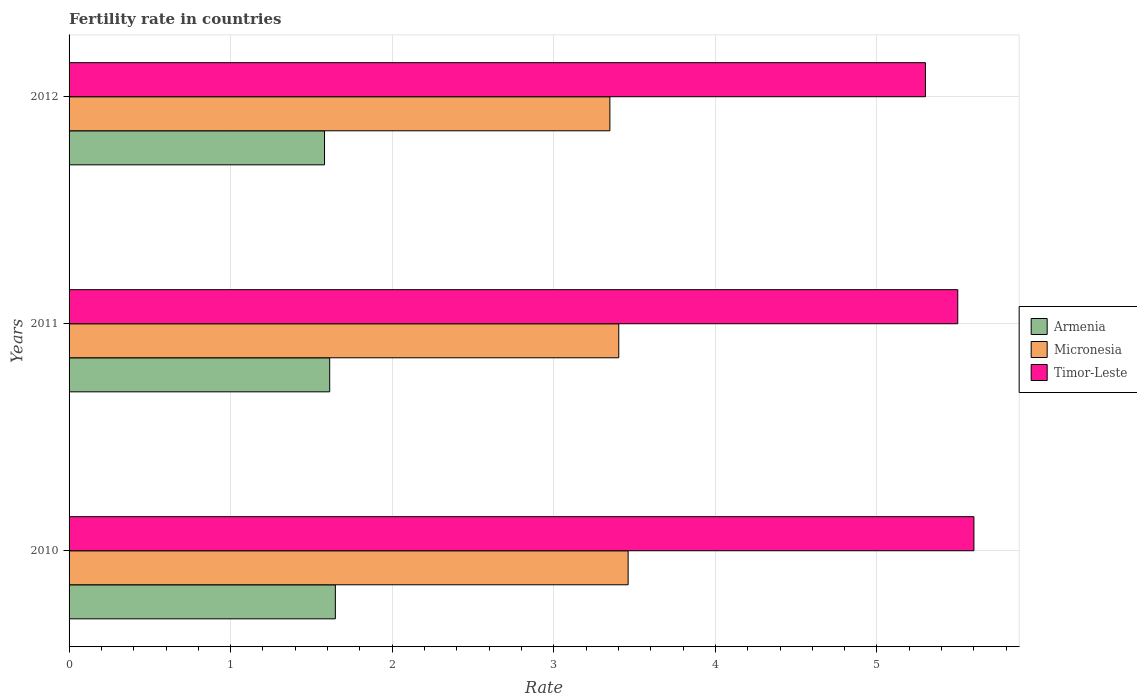How many different coloured bars are there?
Your answer should be very brief. 3. Are the number of bars per tick equal to the number of legend labels?
Offer a very short reply. Yes. Are the number of bars on each tick of the Y-axis equal?
Give a very brief answer. Yes. How many bars are there on the 2nd tick from the top?
Ensure brevity in your answer.  3. In how many cases, is the number of bars for a given year not equal to the number of legend labels?
Your answer should be compact. 0. What is the fertility rate in Armenia in 2010?
Offer a very short reply. 1.65. Across all years, what is the maximum fertility rate in Armenia?
Keep it short and to the point. 1.65. Across all years, what is the minimum fertility rate in Timor-Leste?
Offer a terse response. 5.3. What is the difference between the fertility rate in Armenia in 2010 and that in 2011?
Provide a succinct answer. 0.03. What is the difference between the fertility rate in Armenia in 2011 and the fertility rate in Micronesia in 2012?
Your response must be concise. -1.73. What is the average fertility rate in Timor-Leste per year?
Make the answer very short. 5.47. In the year 2012, what is the difference between the fertility rate in Micronesia and fertility rate in Armenia?
Offer a terse response. 1.77. In how many years, is the fertility rate in Timor-Leste greater than 3.4 ?
Provide a short and direct response. 3. What is the ratio of the fertility rate in Timor-Leste in 2010 to that in 2011?
Provide a succinct answer. 1.02. Is the fertility rate in Armenia in 2011 less than that in 2012?
Provide a short and direct response. No. Is the difference between the fertility rate in Micronesia in 2010 and 2012 greater than the difference between the fertility rate in Armenia in 2010 and 2012?
Offer a terse response. Yes. What is the difference between the highest and the second highest fertility rate in Armenia?
Provide a succinct answer. 0.03. What is the difference between the highest and the lowest fertility rate in Armenia?
Give a very brief answer. 0.07. Is the sum of the fertility rate in Armenia in 2010 and 2011 greater than the maximum fertility rate in Timor-Leste across all years?
Provide a succinct answer. No. What does the 1st bar from the top in 2010 represents?
Keep it short and to the point. Timor-Leste. What does the 1st bar from the bottom in 2010 represents?
Provide a succinct answer. Armenia. How many bars are there?
Keep it short and to the point. 9. Are all the bars in the graph horizontal?
Keep it short and to the point. Yes. How many years are there in the graph?
Offer a very short reply. 3. Are the values on the major ticks of X-axis written in scientific E-notation?
Ensure brevity in your answer.  No. Does the graph contain any zero values?
Provide a succinct answer. No. What is the title of the graph?
Your answer should be compact. Fertility rate in countries. Does "Botswana" appear as one of the legend labels in the graph?
Give a very brief answer. No. What is the label or title of the X-axis?
Offer a very short reply. Rate. What is the Rate of Armenia in 2010?
Provide a succinct answer. 1.65. What is the Rate of Micronesia in 2010?
Your answer should be very brief. 3.46. What is the Rate in Armenia in 2011?
Your answer should be compact. 1.61. What is the Rate in Micronesia in 2011?
Your answer should be compact. 3.4. What is the Rate in Timor-Leste in 2011?
Make the answer very short. 5.5. What is the Rate in Armenia in 2012?
Ensure brevity in your answer.  1.58. What is the Rate of Micronesia in 2012?
Your answer should be compact. 3.35. What is the Rate of Timor-Leste in 2012?
Provide a short and direct response. 5.3. Across all years, what is the maximum Rate of Armenia?
Offer a very short reply. 1.65. Across all years, what is the maximum Rate of Micronesia?
Give a very brief answer. 3.46. Across all years, what is the minimum Rate in Armenia?
Provide a short and direct response. 1.58. Across all years, what is the minimum Rate of Micronesia?
Ensure brevity in your answer.  3.35. Across all years, what is the minimum Rate of Timor-Leste?
Your answer should be compact. 5.3. What is the total Rate in Armenia in the graph?
Your response must be concise. 4.84. What is the total Rate of Micronesia in the graph?
Provide a succinct answer. 10.21. What is the difference between the Rate in Armenia in 2010 and that in 2011?
Provide a succinct answer. 0.04. What is the difference between the Rate in Micronesia in 2010 and that in 2011?
Make the answer very short. 0.06. What is the difference between the Rate of Timor-Leste in 2010 and that in 2011?
Your answer should be compact. 0.1. What is the difference between the Rate in Armenia in 2010 and that in 2012?
Your answer should be compact. 0.07. What is the difference between the Rate in Micronesia in 2010 and that in 2012?
Provide a succinct answer. 0.11. What is the difference between the Rate in Armenia in 2011 and that in 2012?
Ensure brevity in your answer.  0.03. What is the difference between the Rate of Micronesia in 2011 and that in 2012?
Give a very brief answer. 0.06. What is the difference between the Rate of Timor-Leste in 2011 and that in 2012?
Your answer should be compact. 0.2. What is the difference between the Rate of Armenia in 2010 and the Rate of Micronesia in 2011?
Give a very brief answer. -1.75. What is the difference between the Rate of Armenia in 2010 and the Rate of Timor-Leste in 2011?
Keep it short and to the point. -3.85. What is the difference between the Rate of Micronesia in 2010 and the Rate of Timor-Leste in 2011?
Keep it short and to the point. -2.04. What is the difference between the Rate in Armenia in 2010 and the Rate in Micronesia in 2012?
Give a very brief answer. -1.7. What is the difference between the Rate in Armenia in 2010 and the Rate in Timor-Leste in 2012?
Your answer should be very brief. -3.65. What is the difference between the Rate in Micronesia in 2010 and the Rate in Timor-Leste in 2012?
Provide a succinct answer. -1.84. What is the difference between the Rate of Armenia in 2011 and the Rate of Micronesia in 2012?
Your answer should be very brief. -1.73. What is the difference between the Rate in Armenia in 2011 and the Rate in Timor-Leste in 2012?
Provide a succinct answer. -3.69. What is the difference between the Rate in Micronesia in 2011 and the Rate in Timor-Leste in 2012?
Your answer should be very brief. -1.9. What is the average Rate in Armenia per year?
Offer a terse response. 1.61. What is the average Rate of Micronesia per year?
Offer a terse response. 3.4. What is the average Rate of Timor-Leste per year?
Your answer should be very brief. 5.47. In the year 2010, what is the difference between the Rate of Armenia and Rate of Micronesia?
Make the answer very short. -1.81. In the year 2010, what is the difference between the Rate in Armenia and Rate in Timor-Leste?
Ensure brevity in your answer.  -3.95. In the year 2010, what is the difference between the Rate of Micronesia and Rate of Timor-Leste?
Make the answer very short. -2.14. In the year 2011, what is the difference between the Rate in Armenia and Rate in Micronesia?
Ensure brevity in your answer.  -1.79. In the year 2011, what is the difference between the Rate of Armenia and Rate of Timor-Leste?
Ensure brevity in your answer.  -3.89. In the year 2011, what is the difference between the Rate in Micronesia and Rate in Timor-Leste?
Provide a short and direct response. -2.1. In the year 2012, what is the difference between the Rate in Armenia and Rate in Micronesia?
Provide a succinct answer. -1.77. In the year 2012, what is the difference between the Rate of Armenia and Rate of Timor-Leste?
Offer a very short reply. -3.72. In the year 2012, what is the difference between the Rate of Micronesia and Rate of Timor-Leste?
Keep it short and to the point. -1.95. What is the ratio of the Rate of Armenia in 2010 to that in 2011?
Your answer should be compact. 1.02. What is the ratio of the Rate of Timor-Leste in 2010 to that in 2011?
Offer a terse response. 1.02. What is the ratio of the Rate of Armenia in 2010 to that in 2012?
Your answer should be compact. 1.04. What is the ratio of the Rate of Micronesia in 2010 to that in 2012?
Make the answer very short. 1.03. What is the ratio of the Rate in Timor-Leste in 2010 to that in 2012?
Make the answer very short. 1.06. What is the ratio of the Rate of Armenia in 2011 to that in 2012?
Provide a short and direct response. 1.02. What is the ratio of the Rate in Micronesia in 2011 to that in 2012?
Keep it short and to the point. 1.02. What is the ratio of the Rate of Timor-Leste in 2011 to that in 2012?
Make the answer very short. 1.04. What is the difference between the highest and the second highest Rate of Armenia?
Provide a short and direct response. 0.04. What is the difference between the highest and the second highest Rate of Micronesia?
Your answer should be compact. 0.06. What is the difference between the highest and the lowest Rate of Armenia?
Keep it short and to the point. 0.07. What is the difference between the highest and the lowest Rate of Micronesia?
Offer a terse response. 0.11. 